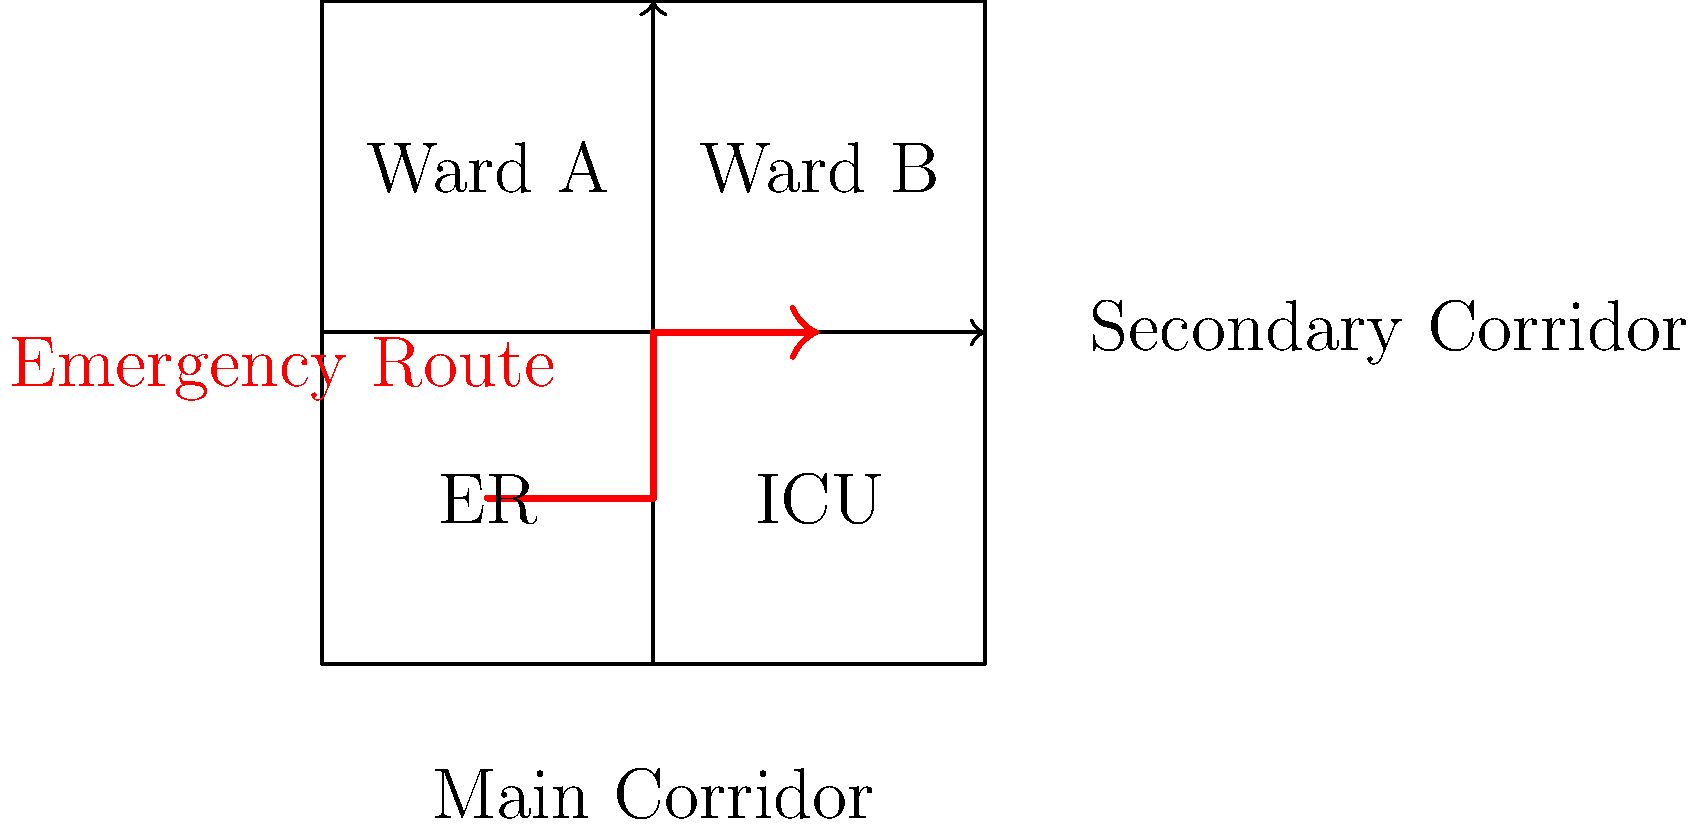In the given hospital layout, what is the most efficient emergency route from the ER to the ICU, and how can this layout be optimized to reduce response time? Consider the impact on overall patient flow and suggest one improvement to enhance both emergency response and general hospital efficiency. 1. Analyze the current layout:
   - The hospital has four main areas: ER, ICU, Ward A, and Ward B.
   - There are two corridors: Main (horizontal) and Secondary (vertical).

2. Identify the emergency route:
   - The most efficient route from ER to ICU is: ER → Main Corridor → ICU.
   - This route minimizes turns and utilizes the main corridor for quick access.

3. Calculate the response time:
   - Assuming each grid unit represents 5 meters, the distance is approximately 40 meters.
   - With an average walking speed of 1.5 m/s, the estimated time is:
     $$ \text{Time} = \frac{\text{Distance}}{\text{Speed}} = \frac{40 \text{ m}}{1.5 \text{ m/s}} \approx 26.7 \text{ seconds} $$

4. Evaluate the impact on patient flow:
   - The current layout separates critical care units (ER and ICU) from wards.
   - The main corridor serves as the primary path for both emergency and regular traffic.

5. Suggest an improvement:
   - Implement a dedicated emergency corridor between ER and ICU.
   - This can be achieved by redesigning the space between these units to include a direct passage.

6. Benefits of the improvement:
   - Reduced emergency response time by eliminating potential obstacles in the main corridor.
   - Improved general patient flow by separating emergency and non-emergency traffic.
   - Enhanced overall hospital efficiency by optimizing the use of space and movement patterns.
Answer: Implement a dedicated emergency corridor between ER and ICU. 